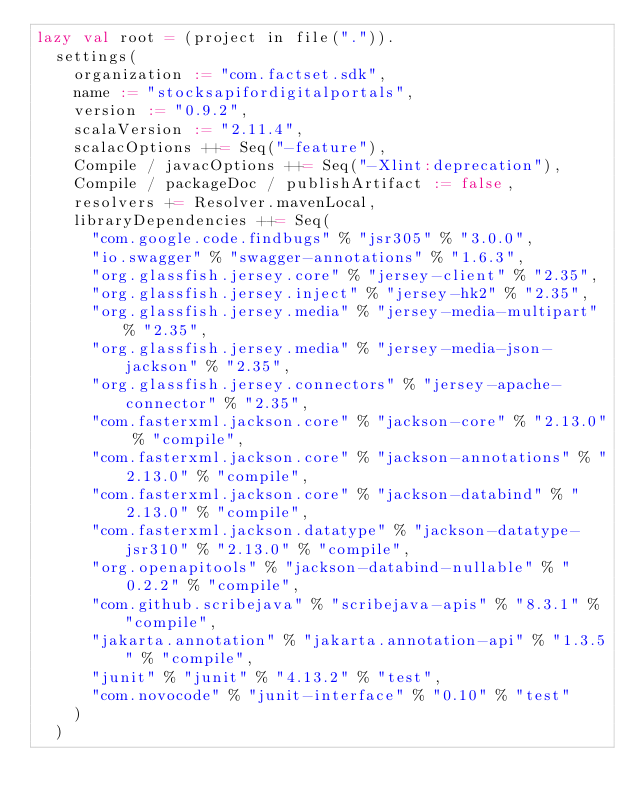Convert code to text. <code><loc_0><loc_0><loc_500><loc_500><_Scala_>lazy val root = (project in file(".")).
  settings(
    organization := "com.factset.sdk",
    name := "stocksapifordigitalportals",
    version := "0.9.2",
    scalaVersion := "2.11.4",
    scalacOptions ++= Seq("-feature"),
    Compile / javacOptions ++= Seq("-Xlint:deprecation"),
    Compile / packageDoc / publishArtifact := false,
    resolvers += Resolver.mavenLocal,
    libraryDependencies ++= Seq(
      "com.google.code.findbugs" % "jsr305" % "3.0.0",
      "io.swagger" % "swagger-annotations" % "1.6.3",
      "org.glassfish.jersey.core" % "jersey-client" % "2.35",
      "org.glassfish.jersey.inject" % "jersey-hk2" % "2.35",
      "org.glassfish.jersey.media" % "jersey-media-multipart" % "2.35",
      "org.glassfish.jersey.media" % "jersey-media-json-jackson" % "2.35",
      "org.glassfish.jersey.connectors" % "jersey-apache-connector" % "2.35",
      "com.fasterxml.jackson.core" % "jackson-core" % "2.13.0" % "compile",
      "com.fasterxml.jackson.core" % "jackson-annotations" % "2.13.0" % "compile",
      "com.fasterxml.jackson.core" % "jackson-databind" % "2.13.0" % "compile",
      "com.fasterxml.jackson.datatype" % "jackson-datatype-jsr310" % "2.13.0" % "compile",
      "org.openapitools" % "jackson-databind-nullable" % "0.2.2" % "compile",
      "com.github.scribejava" % "scribejava-apis" % "8.3.1" % "compile",
      "jakarta.annotation" % "jakarta.annotation-api" % "1.3.5" % "compile",
      "junit" % "junit" % "4.13.2" % "test",
      "com.novocode" % "junit-interface" % "0.10" % "test"
    )
  )
</code> 